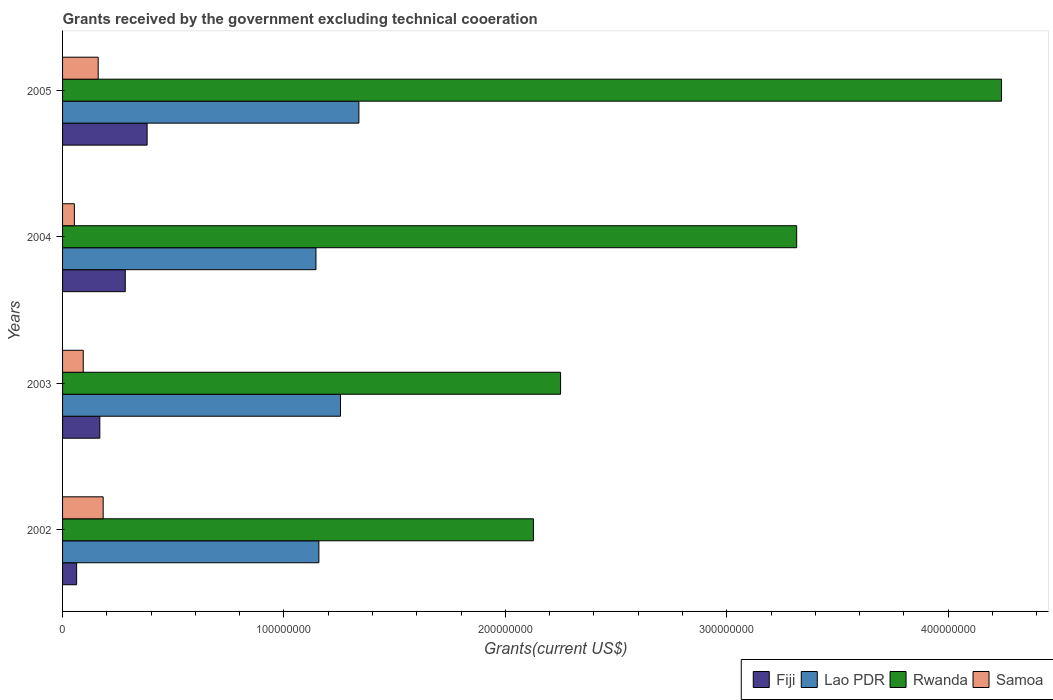How many different coloured bars are there?
Provide a succinct answer. 4. How many bars are there on the 4th tick from the top?
Provide a short and direct response. 4. How many bars are there on the 1st tick from the bottom?
Make the answer very short. 4. What is the total grants received by the government in Rwanda in 2003?
Make the answer very short. 2.25e+08. Across all years, what is the maximum total grants received by the government in Fiji?
Offer a very short reply. 3.82e+07. Across all years, what is the minimum total grants received by the government in Fiji?
Your answer should be very brief. 6.35e+06. In which year was the total grants received by the government in Rwanda maximum?
Keep it short and to the point. 2005. What is the total total grants received by the government in Lao PDR in the graph?
Give a very brief answer. 4.90e+08. What is the difference between the total grants received by the government in Samoa in 2002 and that in 2004?
Provide a short and direct response. 1.30e+07. What is the difference between the total grants received by the government in Rwanda in 2005 and the total grants received by the government in Fiji in 2003?
Provide a succinct answer. 4.07e+08. What is the average total grants received by the government in Lao PDR per year?
Ensure brevity in your answer.  1.22e+08. In the year 2005, what is the difference between the total grants received by the government in Samoa and total grants received by the government in Lao PDR?
Your answer should be very brief. -1.18e+08. What is the ratio of the total grants received by the government in Fiji in 2004 to that in 2005?
Make the answer very short. 0.74. Is the total grants received by the government in Lao PDR in 2002 less than that in 2003?
Make the answer very short. Yes. What is the difference between the highest and the second highest total grants received by the government in Samoa?
Your answer should be compact. 2.24e+06. What is the difference between the highest and the lowest total grants received by the government in Samoa?
Provide a succinct answer. 1.30e+07. Is the sum of the total grants received by the government in Lao PDR in 2004 and 2005 greater than the maximum total grants received by the government in Samoa across all years?
Your answer should be compact. Yes. What does the 3rd bar from the top in 2003 represents?
Make the answer very short. Lao PDR. What does the 3rd bar from the bottom in 2003 represents?
Give a very brief answer. Rwanda. How many bars are there?
Keep it short and to the point. 16. What is the difference between two consecutive major ticks on the X-axis?
Offer a terse response. 1.00e+08. Are the values on the major ticks of X-axis written in scientific E-notation?
Keep it short and to the point. No. Does the graph contain any zero values?
Your answer should be compact. No. Where does the legend appear in the graph?
Keep it short and to the point. Bottom right. How many legend labels are there?
Ensure brevity in your answer.  4. What is the title of the graph?
Offer a very short reply. Grants received by the government excluding technical cooeration. Does "Algeria" appear as one of the legend labels in the graph?
Provide a succinct answer. No. What is the label or title of the X-axis?
Provide a short and direct response. Grants(current US$). What is the label or title of the Y-axis?
Provide a short and direct response. Years. What is the Grants(current US$) of Fiji in 2002?
Offer a very short reply. 6.35e+06. What is the Grants(current US$) of Lao PDR in 2002?
Offer a terse response. 1.16e+08. What is the Grants(current US$) of Rwanda in 2002?
Your response must be concise. 2.13e+08. What is the Grants(current US$) of Samoa in 2002?
Keep it short and to the point. 1.83e+07. What is the Grants(current US$) in Fiji in 2003?
Your answer should be very brief. 1.68e+07. What is the Grants(current US$) in Lao PDR in 2003?
Offer a very short reply. 1.26e+08. What is the Grants(current US$) in Rwanda in 2003?
Ensure brevity in your answer.  2.25e+08. What is the Grants(current US$) in Samoa in 2003?
Your answer should be compact. 9.34e+06. What is the Grants(current US$) in Fiji in 2004?
Provide a short and direct response. 2.83e+07. What is the Grants(current US$) of Lao PDR in 2004?
Give a very brief answer. 1.14e+08. What is the Grants(current US$) in Rwanda in 2004?
Ensure brevity in your answer.  3.32e+08. What is the Grants(current US$) of Samoa in 2004?
Your response must be concise. 5.33e+06. What is the Grants(current US$) in Fiji in 2005?
Your answer should be compact. 3.82e+07. What is the Grants(current US$) of Lao PDR in 2005?
Your answer should be compact. 1.34e+08. What is the Grants(current US$) of Rwanda in 2005?
Make the answer very short. 4.24e+08. What is the Grants(current US$) in Samoa in 2005?
Your response must be concise. 1.61e+07. Across all years, what is the maximum Grants(current US$) in Fiji?
Your answer should be very brief. 3.82e+07. Across all years, what is the maximum Grants(current US$) of Lao PDR?
Your answer should be compact. 1.34e+08. Across all years, what is the maximum Grants(current US$) of Rwanda?
Ensure brevity in your answer.  4.24e+08. Across all years, what is the maximum Grants(current US$) in Samoa?
Your answer should be very brief. 1.83e+07. Across all years, what is the minimum Grants(current US$) of Fiji?
Make the answer very short. 6.35e+06. Across all years, what is the minimum Grants(current US$) of Lao PDR?
Make the answer very short. 1.14e+08. Across all years, what is the minimum Grants(current US$) of Rwanda?
Offer a very short reply. 2.13e+08. Across all years, what is the minimum Grants(current US$) in Samoa?
Your answer should be very brief. 5.33e+06. What is the total Grants(current US$) of Fiji in the graph?
Offer a very short reply. 8.97e+07. What is the total Grants(current US$) in Lao PDR in the graph?
Offer a terse response. 4.90e+08. What is the total Grants(current US$) in Rwanda in the graph?
Offer a very short reply. 1.19e+09. What is the total Grants(current US$) in Samoa in the graph?
Your answer should be very brief. 4.91e+07. What is the difference between the Grants(current US$) of Fiji in 2002 and that in 2003?
Ensure brevity in your answer.  -1.05e+07. What is the difference between the Grants(current US$) in Lao PDR in 2002 and that in 2003?
Offer a terse response. -9.78e+06. What is the difference between the Grants(current US$) of Rwanda in 2002 and that in 2003?
Offer a terse response. -1.23e+07. What is the difference between the Grants(current US$) in Samoa in 2002 and that in 2003?
Offer a very short reply. 9.00e+06. What is the difference between the Grants(current US$) in Fiji in 2002 and that in 2004?
Offer a very short reply. -2.20e+07. What is the difference between the Grants(current US$) of Lao PDR in 2002 and that in 2004?
Keep it short and to the point. 1.31e+06. What is the difference between the Grants(current US$) of Rwanda in 2002 and that in 2004?
Keep it short and to the point. -1.19e+08. What is the difference between the Grants(current US$) of Samoa in 2002 and that in 2004?
Ensure brevity in your answer.  1.30e+07. What is the difference between the Grants(current US$) of Fiji in 2002 and that in 2005?
Give a very brief answer. -3.18e+07. What is the difference between the Grants(current US$) of Lao PDR in 2002 and that in 2005?
Offer a terse response. -1.81e+07. What is the difference between the Grants(current US$) of Rwanda in 2002 and that in 2005?
Keep it short and to the point. -2.11e+08. What is the difference between the Grants(current US$) of Samoa in 2002 and that in 2005?
Provide a succinct answer. 2.24e+06. What is the difference between the Grants(current US$) of Fiji in 2003 and that in 2004?
Your answer should be very brief. -1.15e+07. What is the difference between the Grants(current US$) in Lao PDR in 2003 and that in 2004?
Offer a very short reply. 1.11e+07. What is the difference between the Grants(current US$) of Rwanda in 2003 and that in 2004?
Make the answer very short. -1.07e+08. What is the difference between the Grants(current US$) of Samoa in 2003 and that in 2004?
Provide a succinct answer. 4.01e+06. What is the difference between the Grants(current US$) of Fiji in 2003 and that in 2005?
Keep it short and to the point. -2.14e+07. What is the difference between the Grants(current US$) of Lao PDR in 2003 and that in 2005?
Give a very brief answer. -8.30e+06. What is the difference between the Grants(current US$) of Rwanda in 2003 and that in 2005?
Your response must be concise. -1.99e+08. What is the difference between the Grants(current US$) in Samoa in 2003 and that in 2005?
Make the answer very short. -6.76e+06. What is the difference between the Grants(current US$) of Fiji in 2004 and that in 2005?
Give a very brief answer. -9.87e+06. What is the difference between the Grants(current US$) in Lao PDR in 2004 and that in 2005?
Give a very brief answer. -1.94e+07. What is the difference between the Grants(current US$) of Rwanda in 2004 and that in 2005?
Give a very brief answer. -9.25e+07. What is the difference between the Grants(current US$) in Samoa in 2004 and that in 2005?
Keep it short and to the point. -1.08e+07. What is the difference between the Grants(current US$) in Fiji in 2002 and the Grants(current US$) in Lao PDR in 2003?
Your answer should be very brief. -1.19e+08. What is the difference between the Grants(current US$) in Fiji in 2002 and the Grants(current US$) in Rwanda in 2003?
Offer a very short reply. -2.19e+08. What is the difference between the Grants(current US$) of Fiji in 2002 and the Grants(current US$) of Samoa in 2003?
Make the answer very short. -2.99e+06. What is the difference between the Grants(current US$) of Lao PDR in 2002 and the Grants(current US$) of Rwanda in 2003?
Your answer should be very brief. -1.09e+08. What is the difference between the Grants(current US$) of Lao PDR in 2002 and the Grants(current US$) of Samoa in 2003?
Make the answer very short. 1.06e+08. What is the difference between the Grants(current US$) in Rwanda in 2002 and the Grants(current US$) in Samoa in 2003?
Your answer should be compact. 2.03e+08. What is the difference between the Grants(current US$) in Fiji in 2002 and the Grants(current US$) in Lao PDR in 2004?
Ensure brevity in your answer.  -1.08e+08. What is the difference between the Grants(current US$) in Fiji in 2002 and the Grants(current US$) in Rwanda in 2004?
Ensure brevity in your answer.  -3.25e+08. What is the difference between the Grants(current US$) in Fiji in 2002 and the Grants(current US$) in Samoa in 2004?
Keep it short and to the point. 1.02e+06. What is the difference between the Grants(current US$) in Lao PDR in 2002 and the Grants(current US$) in Rwanda in 2004?
Your answer should be compact. -2.16e+08. What is the difference between the Grants(current US$) in Lao PDR in 2002 and the Grants(current US$) in Samoa in 2004?
Provide a short and direct response. 1.10e+08. What is the difference between the Grants(current US$) in Rwanda in 2002 and the Grants(current US$) in Samoa in 2004?
Provide a succinct answer. 2.07e+08. What is the difference between the Grants(current US$) of Fiji in 2002 and the Grants(current US$) of Lao PDR in 2005?
Make the answer very short. -1.28e+08. What is the difference between the Grants(current US$) of Fiji in 2002 and the Grants(current US$) of Rwanda in 2005?
Your answer should be very brief. -4.18e+08. What is the difference between the Grants(current US$) of Fiji in 2002 and the Grants(current US$) of Samoa in 2005?
Provide a short and direct response. -9.75e+06. What is the difference between the Grants(current US$) in Lao PDR in 2002 and the Grants(current US$) in Rwanda in 2005?
Offer a terse response. -3.08e+08. What is the difference between the Grants(current US$) in Lao PDR in 2002 and the Grants(current US$) in Samoa in 2005?
Offer a terse response. 9.97e+07. What is the difference between the Grants(current US$) of Rwanda in 2002 and the Grants(current US$) of Samoa in 2005?
Your response must be concise. 1.97e+08. What is the difference between the Grants(current US$) of Fiji in 2003 and the Grants(current US$) of Lao PDR in 2004?
Provide a short and direct response. -9.76e+07. What is the difference between the Grants(current US$) in Fiji in 2003 and the Grants(current US$) in Rwanda in 2004?
Make the answer very short. -3.15e+08. What is the difference between the Grants(current US$) in Fiji in 2003 and the Grants(current US$) in Samoa in 2004?
Provide a succinct answer. 1.15e+07. What is the difference between the Grants(current US$) of Lao PDR in 2003 and the Grants(current US$) of Rwanda in 2004?
Give a very brief answer. -2.06e+08. What is the difference between the Grants(current US$) of Lao PDR in 2003 and the Grants(current US$) of Samoa in 2004?
Your answer should be very brief. 1.20e+08. What is the difference between the Grants(current US$) in Rwanda in 2003 and the Grants(current US$) in Samoa in 2004?
Your answer should be compact. 2.20e+08. What is the difference between the Grants(current US$) in Fiji in 2003 and the Grants(current US$) in Lao PDR in 2005?
Your answer should be compact. -1.17e+08. What is the difference between the Grants(current US$) of Fiji in 2003 and the Grants(current US$) of Rwanda in 2005?
Your answer should be compact. -4.07e+08. What is the difference between the Grants(current US$) in Fiji in 2003 and the Grants(current US$) in Samoa in 2005?
Your answer should be compact. 7.30e+05. What is the difference between the Grants(current US$) of Lao PDR in 2003 and the Grants(current US$) of Rwanda in 2005?
Make the answer very short. -2.99e+08. What is the difference between the Grants(current US$) of Lao PDR in 2003 and the Grants(current US$) of Samoa in 2005?
Give a very brief answer. 1.09e+08. What is the difference between the Grants(current US$) in Rwanda in 2003 and the Grants(current US$) in Samoa in 2005?
Make the answer very short. 2.09e+08. What is the difference between the Grants(current US$) in Fiji in 2004 and the Grants(current US$) in Lao PDR in 2005?
Your response must be concise. -1.06e+08. What is the difference between the Grants(current US$) of Fiji in 2004 and the Grants(current US$) of Rwanda in 2005?
Give a very brief answer. -3.96e+08. What is the difference between the Grants(current US$) of Fiji in 2004 and the Grants(current US$) of Samoa in 2005?
Provide a succinct answer. 1.22e+07. What is the difference between the Grants(current US$) in Lao PDR in 2004 and the Grants(current US$) in Rwanda in 2005?
Offer a very short reply. -3.10e+08. What is the difference between the Grants(current US$) in Lao PDR in 2004 and the Grants(current US$) in Samoa in 2005?
Offer a terse response. 9.84e+07. What is the difference between the Grants(current US$) in Rwanda in 2004 and the Grants(current US$) in Samoa in 2005?
Your answer should be compact. 3.16e+08. What is the average Grants(current US$) of Fiji per year?
Your answer should be very brief. 2.24e+07. What is the average Grants(current US$) of Lao PDR per year?
Keep it short and to the point. 1.22e+08. What is the average Grants(current US$) in Rwanda per year?
Keep it short and to the point. 2.98e+08. What is the average Grants(current US$) in Samoa per year?
Give a very brief answer. 1.23e+07. In the year 2002, what is the difference between the Grants(current US$) in Fiji and Grants(current US$) in Lao PDR?
Keep it short and to the point. -1.09e+08. In the year 2002, what is the difference between the Grants(current US$) of Fiji and Grants(current US$) of Rwanda?
Ensure brevity in your answer.  -2.06e+08. In the year 2002, what is the difference between the Grants(current US$) of Fiji and Grants(current US$) of Samoa?
Your answer should be very brief. -1.20e+07. In the year 2002, what is the difference between the Grants(current US$) of Lao PDR and Grants(current US$) of Rwanda?
Your answer should be very brief. -9.69e+07. In the year 2002, what is the difference between the Grants(current US$) in Lao PDR and Grants(current US$) in Samoa?
Keep it short and to the point. 9.74e+07. In the year 2002, what is the difference between the Grants(current US$) of Rwanda and Grants(current US$) of Samoa?
Ensure brevity in your answer.  1.94e+08. In the year 2003, what is the difference between the Grants(current US$) in Fiji and Grants(current US$) in Lao PDR?
Keep it short and to the point. -1.09e+08. In the year 2003, what is the difference between the Grants(current US$) of Fiji and Grants(current US$) of Rwanda?
Your answer should be compact. -2.08e+08. In the year 2003, what is the difference between the Grants(current US$) of Fiji and Grants(current US$) of Samoa?
Ensure brevity in your answer.  7.49e+06. In the year 2003, what is the difference between the Grants(current US$) in Lao PDR and Grants(current US$) in Rwanda?
Offer a terse response. -9.94e+07. In the year 2003, what is the difference between the Grants(current US$) of Lao PDR and Grants(current US$) of Samoa?
Give a very brief answer. 1.16e+08. In the year 2003, what is the difference between the Grants(current US$) of Rwanda and Grants(current US$) of Samoa?
Make the answer very short. 2.16e+08. In the year 2004, what is the difference between the Grants(current US$) of Fiji and Grants(current US$) of Lao PDR?
Provide a succinct answer. -8.61e+07. In the year 2004, what is the difference between the Grants(current US$) in Fiji and Grants(current US$) in Rwanda?
Make the answer very short. -3.03e+08. In the year 2004, what is the difference between the Grants(current US$) of Fiji and Grants(current US$) of Samoa?
Make the answer very short. 2.30e+07. In the year 2004, what is the difference between the Grants(current US$) of Lao PDR and Grants(current US$) of Rwanda?
Make the answer very short. -2.17e+08. In the year 2004, what is the difference between the Grants(current US$) in Lao PDR and Grants(current US$) in Samoa?
Offer a terse response. 1.09e+08. In the year 2004, what is the difference between the Grants(current US$) in Rwanda and Grants(current US$) in Samoa?
Offer a terse response. 3.26e+08. In the year 2005, what is the difference between the Grants(current US$) in Fiji and Grants(current US$) in Lao PDR?
Your response must be concise. -9.57e+07. In the year 2005, what is the difference between the Grants(current US$) in Fiji and Grants(current US$) in Rwanda?
Make the answer very short. -3.86e+08. In the year 2005, what is the difference between the Grants(current US$) in Fiji and Grants(current US$) in Samoa?
Your response must be concise. 2.21e+07. In the year 2005, what is the difference between the Grants(current US$) in Lao PDR and Grants(current US$) in Rwanda?
Make the answer very short. -2.90e+08. In the year 2005, what is the difference between the Grants(current US$) in Lao PDR and Grants(current US$) in Samoa?
Your answer should be compact. 1.18e+08. In the year 2005, what is the difference between the Grants(current US$) in Rwanda and Grants(current US$) in Samoa?
Ensure brevity in your answer.  4.08e+08. What is the ratio of the Grants(current US$) in Fiji in 2002 to that in 2003?
Give a very brief answer. 0.38. What is the ratio of the Grants(current US$) of Lao PDR in 2002 to that in 2003?
Keep it short and to the point. 0.92. What is the ratio of the Grants(current US$) in Rwanda in 2002 to that in 2003?
Offer a terse response. 0.95. What is the ratio of the Grants(current US$) of Samoa in 2002 to that in 2003?
Ensure brevity in your answer.  1.96. What is the ratio of the Grants(current US$) in Fiji in 2002 to that in 2004?
Provide a short and direct response. 0.22. What is the ratio of the Grants(current US$) in Lao PDR in 2002 to that in 2004?
Your response must be concise. 1.01. What is the ratio of the Grants(current US$) in Rwanda in 2002 to that in 2004?
Keep it short and to the point. 0.64. What is the ratio of the Grants(current US$) in Samoa in 2002 to that in 2004?
Provide a succinct answer. 3.44. What is the ratio of the Grants(current US$) in Fiji in 2002 to that in 2005?
Ensure brevity in your answer.  0.17. What is the ratio of the Grants(current US$) in Lao PDR in 2002 to that in 2005?
Offer a very short reply. 0.86. What is the ratio of the Grants(current US$) of Rwanda in 2002 to that in 2005?
Provide a short and direct response. 0.5. What is the ratio of the Grants(current US$) of Samoa in 2002 to that in 2005?
Provide a succinct answer. 1.14. What is the ratio of the Grants(current US$) of Fiji in 2003 to that in 2004?
Ensure brevity in your answer.  0.59. What is the ratio of the Grants(current US$) of Lao PDR in 2003 to that in 2004?
Your answer should be very brief. 1.1. What is the ratio of the Grants(current US$) of Rwanda in 2003 to that in 2004?
Offer a terse response. 0.68. What is the ratio of the Grants(current US$) of Samoa in 2003 to that in 2004?
Give a very brief answer. 1.75. What is the ratio of the Grants(current US$) of Fiji in 2003 to that in 2005?
Make the answer very short. 0.44. What is the ratio of the Grants(current US$) of Lao PDR in 2003 to that in 2005?
Ensure brevity in your answer.  0.94. What is the ratio of the Grants(current US$) of Rwanda in 2003 to that in 2005?
Provide a short and direct response. 0.53. What is the ratio of the Grants(current US$) of Samoa in 2003 to that in 2005?
Make the answer very short. 0.58. What is the ratio of the Grants(current US$) in Fiji in 2004 to that in 2005?
Your answer should be compact. 0.74. What is the ratio of the Grants(current US$) in Lao PDR in 2004 to that in 2005?
Provide a short and direct response. 0.86. What is the ratio of the Grants(current US$) in Rwanda in 2004 to that in 2005?
Your answer should be compact. 0.78. What is the ratio of the Grants(current US$) of Samoa in 2004 to that in 2005?
Offer a very short reply. 0.33. What is the difference between the highest and the second highest Grants(current US$) of Fiji?
Provide a short and direct response. 9.87e+06. What is the difference between the highest and the second highest Grants(current US$) in Lao PDR?
Ensure brevity in your answer.  8.30e+06. What is the difference between the highest and the second highest Grants(current US$) of Rwanda?
Your answer should be very brief. 9.25e+07. What is the difference between the highest and the second highest Grants(current US$) in Samoa?
Your answer should be compact. 2.24e+06. What is the difference between the highest and the lowest Grants(current US$) of Fiji?
Keep it short and to the point. 3.18e+07. What is the difference between the highest and the lowest Grants(current US$) of Lao PDR?
Offer a terse response. 1.94e+07. What is the difference between the highest and the lowest Grants(current US$) of Rwanda?
Offer a terse response. 2.11e+08. What is the difference between the highest and the lowest Grants(current US$) in Samoa?
Your answer should be compact. 1.30e+07. 